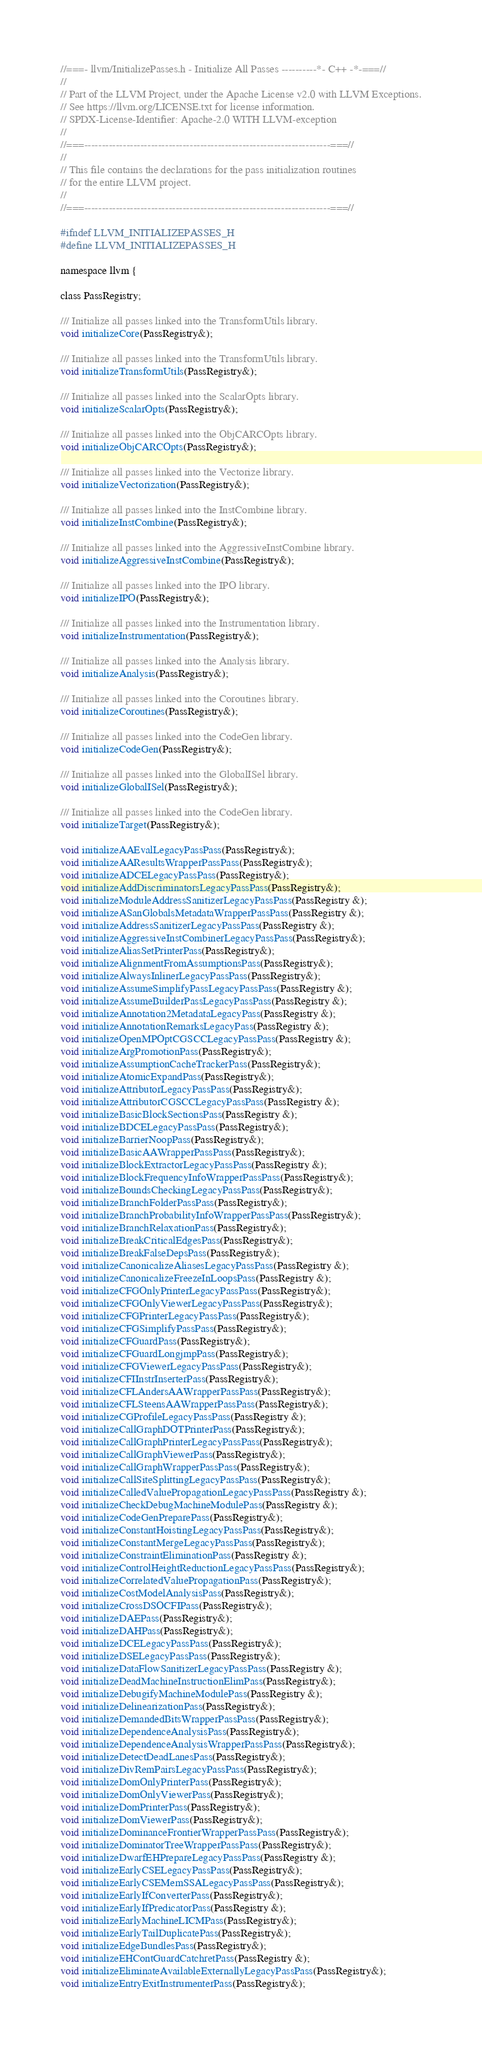Convert code to text. <code><loc_0><loc_0><loc_500><loc_500><_C_>//===- llvm/InitializePasses.h - Initialize All Passes ----------*- C++ -*-===//
//
// Part of the LLVM Project, under the Apache License v2.0 with LLVM Exceptions.
// See https://llvm.org/LICENSE.txt for license information.
// SPDX-License-Identifier: Apache-2.0 WITH LLVM-exception
//
//===----------------------------------------------------------------------===//
//
// This file contains the declarations for the pass initialization routines
// for the entire LLVM project.
//
//===----------------------------------------------------------------------===//

#ifndef LLVM_INITIALIZEPASSES_H
#define LLVM_INITIALIZEPASSES_H

namespace llvm {

class PassRegistry;

/// Initialize all passes linked into the TransformUtils library.
void initializeCore(PassRegistry&);

/// Initialize all passes linked into the TransformUtils library.
void initializeTransformUtils(PassRegistry&);

/// Initialize all passes linked into the ScalarOpts library.
void initializeScalarOpts(PassRegistry&);

/// Initialize all passes linked into the ObjCARCOpts library.
void initializeObjCARCOpts(PassRegistry&);

/// Initialize all passes linked into the Vectorize library.
void initializeVectorization(PassRegistry&);

/// Initialize all passes linked into the InstCombine library.
void initializeInstCombine(PassRegistry&);

/// Initialize all passes linked into the AggressiveInstCombine library.
void initializeAggressiveInstCombine(PassRegistry&);

/// Initialize all passes linked into the IPO library.
void initializeIPO(PassRegistry&);

/// Initialize all passes linked into the Instrumentation library.
void initializeInstrumentation(PassRegistry&);

/// Initialize all passes linked into the Analysis library.
void initializeAnalysis(PassRegistry&);

/// Initialize all passes linked into the Coroutines library.
void initializeCoroutines(PassRegistry&);

/// Initialize all passes linked into the CodeGen library.
void initializeCodeGen(PassRegistry&);

/// Initialize all passes linked into the GlobalISel library.
void initializeGlobalISel(PassRegistry&);

/// Initialize all passes linked into the CodeGen library.
void initializeTarget(PassRegistry&);

void initializeAAEvalLegacyPassPass(PassRegistry&);
void initializeAAResultsWrapperPassPass(PassRegistry&);
void initializeADCELegacyPassPass(PassRegistry&);
void initializeAddDiscriminatorsLegacyPassPass(PassRegistry&);
void initializeModuleAddressSanitizerLegacyPassPass(PassRegistry &);
void initializeASanGlobalsMetadataWrapperPassPass(PassRegistry &);
void initializeAddressSanitizerLegacyPassPass(PassRegistry &);
void initializeAggressiveInstCombinerLegacyPassPass(PassRegistry&);
void initializeAliasSetPrinterPass(PassRegistry&);
void initializeAlignmentFromAssumptionsPass(PassRegistry&);
void initializeAlwaysInlinerLegacyPassPass(PassRegistry&);
void initializeAssumeSimplifyPassLegacyPassPass(PassRegistry &);
void initializeAssumeBuilderPassLegacyPassPass(PassRegistry &);
void initializeAnnotation2MetadataLegacyPass(PassRegistry &);
void initializeAnnotationRemarksLegacyPass(PassRegistry &);
void initializeOpenMPOptCGSCCLegacyPassPass(PassRegistry &);
void initializeArgPromotionPass(PassRegistry&);
void initializeAssumptionCacheTrackerPass(PassRegistry&);
void initializeAtomicExpandPass(PassRegistry&);
void initializeAttributorLegacyPassPass(PassRegistry&);
void initializeAttributorCGSCCLegacyPassPass(PassRegistry &);
void initializeBasicBlockSectionsPass(PassRegistry &);
void initializeBDCELegacyPassPass(PassRegistry&);
void initializeBarrierNoopPass(PassRegistry&);
void initializeBasicAAWrapperPassPass(PassRegistry&);
void initializeBlockExtractorLegacyPassPass(PassRegistry &);
void initializeBlockFrequencyInfoWrapperPassPass(PassRegistry&);
void initializeBoundsCheckingLegacyPassPass(PassRegistry&);
void initializeBranchFolderPassPass(PassRegistry&);
void initializeBranchProbabilityInfoWrapperPassPass(PassRegistry&);
void initializeBranchRelaxationPass(PassRegistry&);
void initializeBreakCriticalEdgesPass(PassRegistry&);
void initializeBreakFalseDepsPass(PassRegistry&);
void initializeCanonicalizeAliasesLegacyPassPass(PassRegistry &);
void initializeCanonicalizeFreezeInLoopsPass(PassRegistry &);
void initializeCFGOnlyPrinterLegacyPassPass(PassRegistry&);
void initializeCFGOnlyViewerLegacyPassPass(PassRegistry&);
void initializeCFGPrinterLegacyPassPass(PassRegistry&);
void initializeCFGSimplifyPassPass(PassRegistry&);
void initializeCFGuardPass(PassRegistry&);
void initializeCFGuardLongjmpPass(PassRegistry&);
void initializeCFGViewerLegacyPassPass(PassRegistry&);
void initializeCFIInstrInserterPass(PassRegistry&);
void initializeCFLAndersAAWrapperPassPass(PassRegistry&);
void initializeCFLSteensAAWrapperPassPass(PassRegistry&);
void initializeCGProfileLegacyPassPass(PassRegistry &);
void initializeCallGraphDOTPrinterPass(PassRegistry&);
void initializeCallGraphPrinterLegacyPassPass(PassRegistry&);
void initializeCallGraphViewerPass(PassRegistry&);
void initializeCallGraphWrapperPassPass(PassRegistry&);
void initializeCallSiteSplittingLegacyPassPass(PassRegistry&);
void initializeCalledValuePropagationLegacyPassPass(PassRegistry &);
void initializeCheckDebugMachineModulePass(PassRegistry &);
void initializeCodeGenPreparePass(PassRegistry&);
void initializeConstantHoistingLegacyPassPass(PassRegistry&);
void initializeConstantMergeLegacyPassPass(PassRegistry&);
void initializeConstraintEliminationPass(PassRegistry &);
void initializeControlHeightReductionLegacyPassPass(PassRegistry&);
void initializeCorrelatedValuePropagationPass(PassRegistry&);
void initializeCostModelAnalysisPass(PassRegistry&);
void initializeCrossDSOCFIPass(PassRegistry&);
void initializeDAEPass(PassRegistry&);
void initializeDAHPass(PassRegistry&);
void initializeDCELegacyPassPass(PassRegistry&);
void initializeDSELegacyPassPass(PassRegistry&);
void initializeDataFlowSanitizerLegacyPassPass(PassRegistry &);
void initializeDeadMachineInstructionElimPass(PassRegistry&);
void initializeDebugifyMachineModulePass(PassRegistry &);
void initializeDelinearizationPass(PassRegistry&);
void initializeDemandedBitsWrapperPassPass(PassRegistry&);
void initializeDependenceAnalysisPass(PassRegistry&);
void initializeDependenceAnalysisWrapperPassPass(PassRegistry&);
void initializeDetectDeadLanesPass(PassRegistry&);
void initializeDivRemPairsLegacyPassPass(PassRegistry&);
void initializeDomOnlyPrinterPass(PassRegistry&);
void initializeDomOnlyViewerPass(PassRegistry&);
void initializeDomPrinterPass(PassRegistry&);
void initializeDomViewerPass(PassRegistry&);
void initializeDominanceFrontierWrapperPassPass(PassRegistry&);
void initializeDominatorTreeWrapperPassPass(PassRegistry&);
void initializeDwarfEHPrepareLegacyPassPass(PassRegistry &);
void initializeEarlyCSELegacyPassPass(PassRegistry&);
void initializeEarlyCSEMemSSALegacyPassPass(PassRegistry&);
void initializeEarlyIfConverterPass(PassRegistry&);
void initializeEarlyIfPredicatorPass(PassRegistry &);
void initializeEarlyMachineLICMPass(PassRegistry&);
void initializeEarlyTailDuplicatePass(PassRegistry&);
void initializeEdgeBundlesPass(PassRegistry&);
void initializeEHContGuardCatchretPass(PassRegistry &);
void initializeEliminateAvailableExternallyLegacyPassPass(PassRegistry&);
void initializeEntryExitInstrumenterPass(PassRegistry&);</code> 